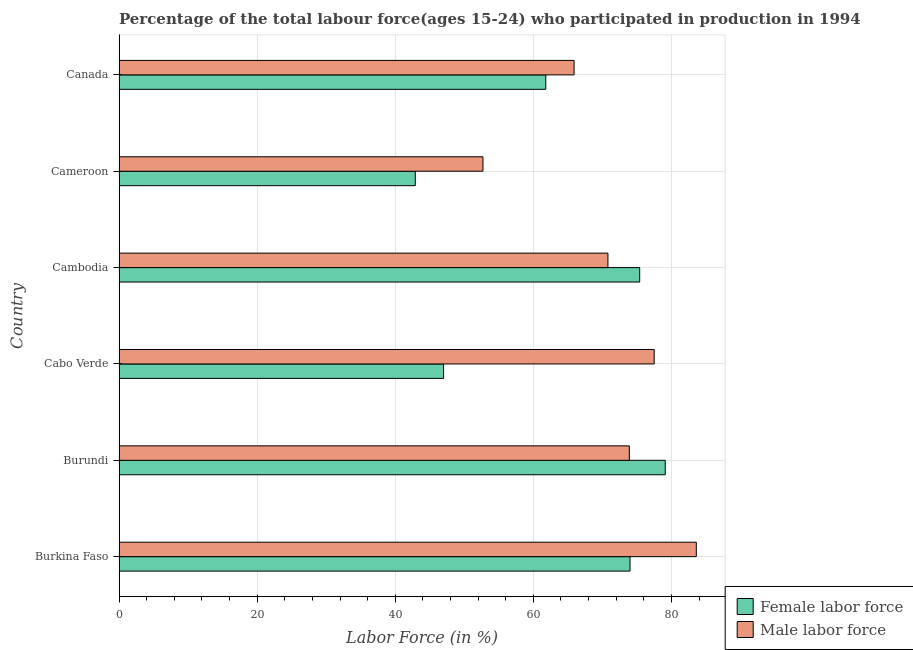How many different coloured bars are there?
Offer a terse response. 2. How many groups of bars are there?
Ensure brevity in your answer.  6. Are the number of bars per tick equal to the number of legend labels?
Provide a short and direct response. Yes. How many bars are there on the 2nd tick from the top?
Give a very brief answer. 2. What is the label of the 6th group of bars from the top?
Offer a very short reply. Burkina Faso. In how many cases, is the number of bars for a given country not equal to the number of legend labels?
Keep it short and to the point. 0. What is the percentage of female labor force in Canada?
Ensure brevity in your answer.  61.8. Across all countries, what is the maximum percentage of female labor force?
Offer a very short reply. 79.1. Across all countries, what is the minimum percentage of male labour force?
Keep it short and to the point. 52.7. In which country was the percentage of female labor force maximum?
Provide a short and direct response. Burundi. In which country was the percentage of female labor force minimum?
Offer a very short reply. Cameroon. What is the total percentage of male labour force in the graph?
Give a very brief answer. 424.4. What is the difference between the percentage of male labour force in Canada and the percentage of female labor force in Burkina Faso?
Provide a short and direct response. -8.1. What is the average percentage of female labor force per country?
Your response must be concise. 63.37. What is the difference between the percentage of female labor force and percentage of male labour force in Cameroon?
Offer a very short reply. -9.8. In how many countries, is the percentage of male labour force greater than 76 %?
Your answer should be very brief. 2. What is the ratio of the percentage of male labour force in Burkina Faso to that in Cambodia?
Provide a short and direct response. 1.18. Is the percentage of female labor force in Burkina Faso less than that in Cameroon?
Your answer should be compact. No. Is the difference between the percentage of male labour force in Burkina Faso and Cabo Verde greater than the difference between the percentage of female labor force in Burkina Faso and Cabo Verde?
Your response must be concise. No. What is the difference between the highest and the lowest percentage of female labor force?
Your response must be concise. 36.2. Is the sum of the percentage of female labor force in Burkina Faso and Burundi greater than the maximum percentage of male labour force across all countries?
Provide a succinct answer. Yes. What does the 2nd bar from the top in Burundi represents?
Your answer should be compact. Female labor force. What does the 2nd bar from the bottom in Burkina Faso represents?
Your answer should be compact. Male labor force. Are all the bars in the graph horizontal?
Provide a short and direct response. Yes. What is the difference between two consecutive major ticks on the X-axis?
Your answer should be compact. 20. Where does the legend appear in the graph?
Your response must be concise. Bottom right. How many legend labels are there?
Your answer should be compact. 2. What is the title of the graph?
Offer a very short reply. Percentage of the total labour force(ages 15-24) who participated in production in 1994. What is the label or title of the X-axis?
Ensure brevity in your answer.  Labor Force (in %). What is the Labor Force (in %) of Male labor force in Burkina Faso?
Your response must be concise. 83.6. What is the Labor Force (in %) in Female labor force in Burundi?
Provide a short and direct response. 79.1. What is the Labor Force (in %) of Male labor force in Burundi?
Give a very brief answer. 73.9. What is the Labor Force (in %) in Male labor force in Cabo Verde?
Give a very brief answer. 77.5. What is the Labor Force (in %) in Female labor force in Cambodia?
Keep it short and to the point. 75.4. What is the Labor Force (in %) in Male labor force in Cambodia?
Ensure brevity in your answer.  70.8. What is the Labor Force (in %) in Female labor force in Cameroon?
Offer a very short reply. 42.9. What is the Labor Force (in %) in Male labor force in Cameroon?
Provide a succinct answer. 52.7. What is the Labor Force (in %) in Female labor force in Canada?
Your answer should be very brief. 61.8. What is the Labor Force (in %) of Male labor force in Canada?
Offer a terse response. 65.9. Across all countries, what is the maximum Labor Force (in %) of Female labor force?
Provide a short and direct response. 79.1. Across all countries, what is the maximum Labor Force (in %) of Male labor force?
Your answer should be compact. 83.6. Across all countries, what is the minimum Labor Force (in %) of Female labor force?
Offer a terse response. 42.9. Across all countries, what is the minimum Labor Force (in %) of Male labor force?
Provide a succinct answer. 52.7. What is the total Labor Force (in %) in Female labor force in the graph?
Ensure brevity in your answer.  380.2. What is the total Labor Force (in %) in Male labor force in the graph?
Offer a very short reply. 424.4. What is the difference between the Labor Force (in %) in Female labor force in Burkina Faso and that in Burundi?
Your answer should be very brief. -5.1. What is the difference between the Labor Force (in %) in Male labor force in Burkina Faso and that in Burundi?
Ensure brevity in your answer.  9.7. What is the difference between the Labor Force (in %) in Male labor force in Burkina Faso and that in Cambodia?
Provide a short and direct response. 12.8. What is the difference between the Labor Force (in %) of Female labor force in Burkina Faso and that in Cameroon?
Keep it short and to the point. 31.1. What is the difference between the Labor Force (in %) of Male labor force in Burkina Faso and that in Cameroon?
Offer a very short reply. 30.9. What is the difference between the Labor Force (in %) of Male labor force in Burkina Faso and that in Canada?
Provide a short and direct response. 17.7. What is the difference between the Labor Force (in %) of Female labor force in Burundi and that in Cabo Verde?
Provide a short and direct response. 32.1. What is the difference between the Labor Force (in %) of Female labor force in Burundi and that in Cambodia?
Offer a terse response. 3.7. What is the difference between the Labor Force (in %) of Female labor force in Burundi and that in Cameroon?
Your answer should be compact. 36.2. What is the difference between the Labor Force (in %) in Male labor force in Burundi and that in Cameroon?
Your answer should be compact. 21.2. What is the difference between the Labor Force (in %) in Female labor force in Burundi and that in Canada?
Provide a succinct answer. 17.3. What is the difference between the Labor Force (in %) of Female labor force in Cabo Verde and that in Cambodia?
Make the answer very short. -28.4. What is the difference between the Labor Force (in %) of Male labor force in Cabo Verde and that in Cambodia?
Offer a terse response. 6.7. What is the difference between the Labor Force (in %) of Female labor force in Cabo Verde and that in Cameroon?
Your answer should be very brief. 4.1. What is the difference between the Labor Force (in %) in Male labor force in Cabo Verde and that in Cameroon?
Offer a terse response. 24.8. What is the difference between the Labor Force (in %) of Female labor force in Cabo Verde and that in Canada?
Offer a terse response. -14.8. What is the difference between the Labor Force (in %) in Female labor force in Cambodia and that in Cameroon?
Ensure brevity in your answer.  32.5. What is the difference between the Labor Force (in %) of Male labor force in Cambodia and that in Canada?
Make the answer very short. 4.9. What is the difference between the Labor Force (in %) of Female labor force in Cameroon and that in Canada?
Give a very brief answer. -18.9. What is the difference between the Labor Force (in %) in Female labor force in Burkina Faso and the Labor Force (in %) in Male labor force in Cameroon?
Keep it short and to the point. 21.3. What is the difference between the Labor Force (in %) of Female labor force in Burkina Faso and the Labor Force (in %) of Male labor force in Canada?
Give a very brief answer. 8.1. What is the difference between the Labor Force (in %) in Female labor force in Burundi and the Labor Force (in %) in Male labor force in Cambodia?
Provide a succinct answer. 8.3. What is the difference between the Labor Force (in %) of Female labor force in Burundi and the Labor Force (in %) of Male labor force in Cameroon?
Your answer should be very brief. 26.4. What is the difference between the Labor Force (in %) in Female labor force in Burundi and the Labor Force (in %) in Male labor force in Canada?
Offer a terse response. 13.2. What is the difference between the Labor Force (in %) of Female labor force in Cabo Verde and the Labor Force (in %) of Male labor force in Cambodia?
Give a very brief answer. -23.8. What is the difference between the Labor Force (in %) of Female labor force in Cabo Verde and the Labor Force (in %) of Male labor force in Canada?
Provide a short and direct response. -18.9. What is the difference between the Labor Force (in %) of Female labor force in Cambodia and the Labor Force (in %) of Male labor force in Cameroon?
Make the answer very short. 22.7. What is the average Labor Force (in %) of Female labor force per country?
Your answer should be compact. 63.37. What is the average Labor Force (in %) of Male labor force per country?
Provide a short and direct response. 70.73. What is the difference between the Labor Force (in %) of Female labor force and Labor Force (in %) of Male labor force in Burundi?
Provide a succinct answer. 5.2. What is the difference between the Labor Force (in %) in Female labor force and Labor Force (in %) in Male labor force in Cabo Verde?
Keep it short and to the point. -30.5. What is the difference between the Labor Force (in %) in Female labor force and Labor Force (in %) in Male labor force in Canada?
Your answer should be compact. -4.1. What is the ratio of the Labor Force (in %) in Female labor force in Burkina Faso to that in Burundi?
Your answer should be compact. 0.94. What is the ratio of the Labor Force (in %) in Male labor force in Burkina Faso to that in Burundi?
Keep it short and to the point. 1.13. What is the ratio of the Labor Force (in %) of Female labor force in Burkina Faso to that in Cabo Verde?
Provide a short and direct response. 1.57. What is the ratio of the Labor Force (in %) of Male labor force in Burkina Faso to that in Cabo Verde?
Provide a short and direct response. 1.08. What is the ratio of the Labor Force (in %) in Female labor force in Burkina Faso to that in Cambodia?
Ensure brevity in your answer.  0.98. What is the ratio of the Labor Force (in %) in Male labor force in Burkina Faso to that in Cambodia?
Provide a succinct answer. 1.18. What is the ratio of the Labor Force (in %) in Female labor force in Burkina Faso to that in Cameroon?
Offer a very short reply. 1.72. What is the ratio of the Labor Force (in %) of Male labor force in Burkina Faso to that in Cameroon?
Give a very brief answer. 1.59. What is the ratio of the Labor Force (in %) of Female labor force in Burkina Faso to that in Canada?
Keep it short and to the point. 1.2. What is the ratio of the Labor Force (in %) of Male labor force in Burkina Faso to that in Canada?
Offer a very short reply. 1.27. What is the ratio of the Labor Force (in %) in Female labor force in Burundi to that in Cabo Verde?
Make the answer very short. 1.68. What is the ratio of the Labor Force (in %) in Male labor force in Burundi to that in Cabo Verde?
Offer a very short reply. 0.95. What is the ratio of the Labor Force (in %) of Female labor force in Burundi to that in Cambodia?
Offer a very short reply. 1.05. What is the ratio of the Labor Force (in %) of Male labor force in Burundi to that in Cambodia?
Offer a terse response. 1.04. What is the ratio of the Labor Force (in %) in Female labor force in Burundi to that in Cameroon?
Your answer should be compact. 1.84. What is the ratio of the Labor Force (in %) of Male labor force in Burundi to that in Cameroon?
Give a very brief answer. 1.4. What is the ratio of the Labor Force (in %) of Female labor force in Burundi to that in Canada?
Your answer should be very brief. 1.28. What is the ratio of the Labor Force (in %) in Male labor force in Burundi to that in Canada?
Give a very brief answer. 1.12. What is the ratio of the Labor Force (in %) of Female labor force in Cabo Verde to that in Cambodia?
Ensure brevity in your answer.  0.62. What is the ratio of the Labor Force (in %) in Male labor force in Cabo Verde to that in Cambodia?
Offer a very short reply. 1.09. What is the ratio of the Labor Force (in %) in Female labor force in Cabo Verde to that in Cameroon?
Keep it short and to the point. 1.1. What is the ratio of the Labor Force (in %) in Male labor force in Cabo Verde to that in Cameroon?
Ensure brevity in your answer.  1.47. What is the ratio of the Labor Force (in %) in Female labor force in Cabo Verde to that in Canada?
Keep it short and to the point. 0.76. What is the ratio of the Labor Force (in %) of Male labor force in Cabo Verde to that in Canada?
Your answer should be compact. 1.18. What is the ratio of the Labor Force (in %) of Female labor force in Cambodia to that in Cameroon?
Provide a succinct answer. 1.76. What is the ratio of the Labor Force (in %) of Male labor force in Cambodia to that in Cameroon?
Your answer should be very brief. 1.34. What is the ratio of the Labor Force (in %) of Female labor force in Cambodia to that in Canada?
Provide a succinct answer. 1.22. What is the ratio of the Labor Force (in %) in Male labor force in Cambodia to that in Canada?
Provide a short and direct response. 1.07. What is the ratio of the Labor Force (in %) in Female labor force in Cameroon to that in Canada?
Your answer should be very brief. 0.69. What is the ratio of the Labor Force (in %) in Male labor force in Cameroon to that in Canada?
Provide a short and direct response. 0.8. What is the difference between the highest and the second highest Labor Force (in %) of Female labor force?
Your answer should be compact. 3.7. What is the difference between the highest and the lowest Labor Force (in %) of Female labor force?
Offer a terse response. 36.2. What is the difference between the highest and the lowest Labor Force (in %) in Male labor force?
Offer a terse response. 30.9. 